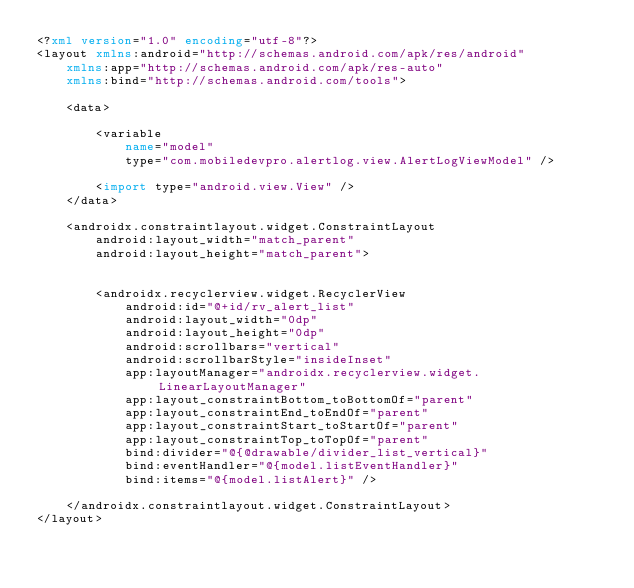Convert code to text. <code><loc_0><loc_0><loc_500><loc_500><_XML_><?xml version="1.0" encoding="utf-8"?>
<layout xmlns:android="http://schemas.android.com/apk/res/android"
    xmlns:app="http://schemas.android.com/apk/res-auto"
    xmlns:bind="http://schemas.android.com/tools">

    <data>

        <variable
            name="model"
            type="com.mobiledevpro.alertlog.view.AlertLogViewModel" />

        <import type="android.view.View" />
    </data>

    <androidx.constraintlayout.widget.ConstraintLayout
        android:layout_width="match_parent"
        android:layout_height="match_parent">


        <androidx.recyclerview.widget.RecyclerView
            android:id="@+id/rv_alert_list"
            android:layout_width="0dp"
            android:layout_height="0dp"
            android:scrollbars="vertical"
            android:scrollbarStyle="insideInset"
            app:layoutManager="androidx.recyclerview.widget.LinearLayoutManager"
            app:layout_constraintBottom_toBottomOf="parent"
            app:layout_constraintEnd_toEndOf="parent"
            app:layout_constraintStart_toStartOf="parent"
            app:layout_constraintTop_toTopOf="parent"
            bind:divider="@{@drawable/divider_list_vertical}"
            bind:eventHandler="@{model.listEventHandler}"
            bind:items="@{model.listAlert}" />

    </androidx.constraintlayout.widget.ConstraintLayout>
</layout></code> 